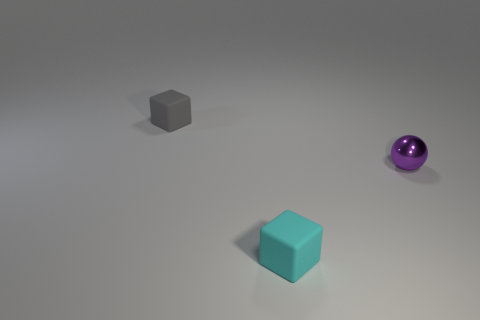Is there anything else that has the same material as the purple ball?
Offer a terse response. No. The small thing that is both to the left of the metal ball and behind the tiny cyan block is made of what material?
Offer a very short reply. Rubber. There is a purple object that is the same size as the gray matte block; what material is it?
Offer a very short reply. Metal. Is there another tiny block that has the same material as the cyan block?
Make the answer very short. Yes. How many large green rubber things are there?
Ensure brevity in your answer.  0. Is the material of the gray object the same as the purple thing on the right side of the tiny gray matte object?
Provide a short and direct response. No. What number of matte objects are the same color as the small ball?
Make the answer very short. 0. There is a gray thing; is it the same shape as the cyan thing that is on the left side of the tiny metallic thing?
Offer a terse response. Yes. There is another tiny object that is the same material as the cyan thing; what is its color?
Ensure brevity in your answer.  Gray. Are there fewer tiny gray rubber things that are in front of the small cyan cube than small blue rubber blocks?
Your response must be concise. No. 